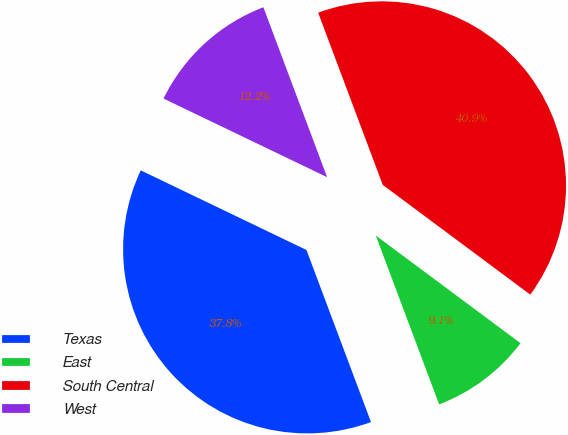Convert chart to OTSL. <chart><loc_0><loc_0><loc_500><loc_500><pie_chart><fcel>Texas<fcel>East<fcel>South Central<fcel>West<nl><fcel>37.84%<fcel>9.11%<fcel>40.89%<fcel>12.16%<nl></chart> 